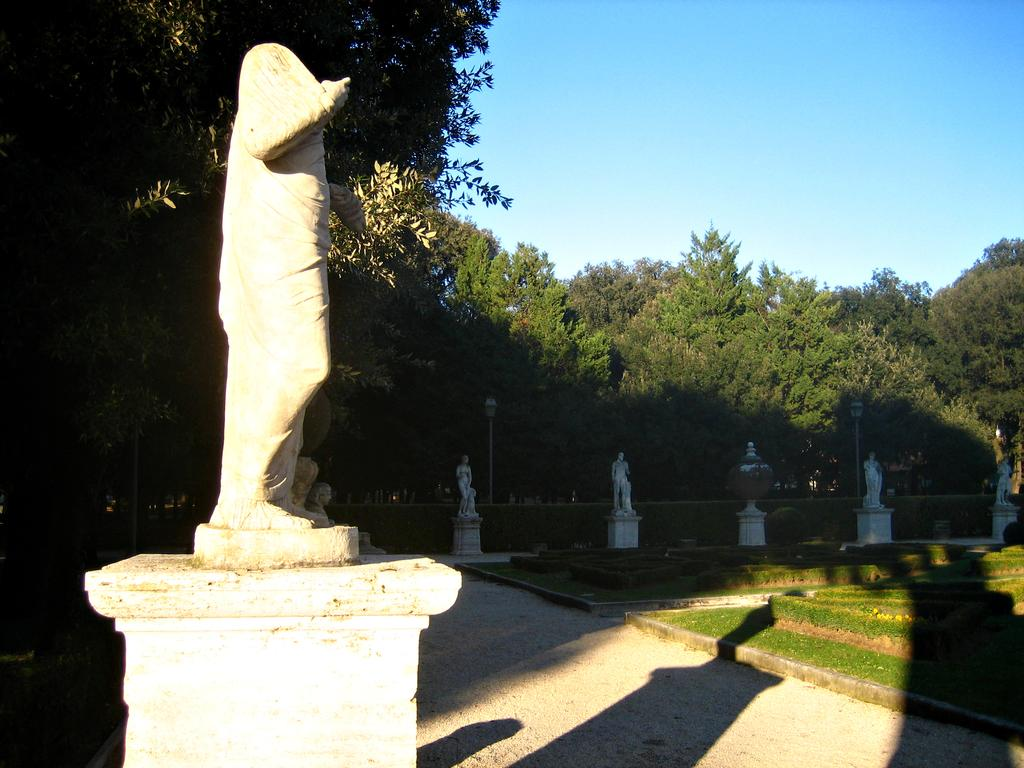What can be found towards the left side of the image? There are statues towards the left side of the image. Are there any statues in other parts of the image? Yes, there are more statues in the center of the image. What is in front of the statues? There is grass in front of the statues. What can be seen in the background of the image? There are trees and the sky visible in the background of the image. What type of sweater is draped over the statue in the image? There is no sweater present in the image; the statues are not wearing any clothing. Can you describe the tail of the insect on the statue in the image? There is no insect present in the image, so it is not possible to describe its tail. 